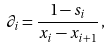<formula> <loc_0><loc_0><loc_500><loc_500>\partial _ { i } = \frac { 1 - s _ { i } } { x _ { i } - x _ { i + 1 } } \, ,</formula> 